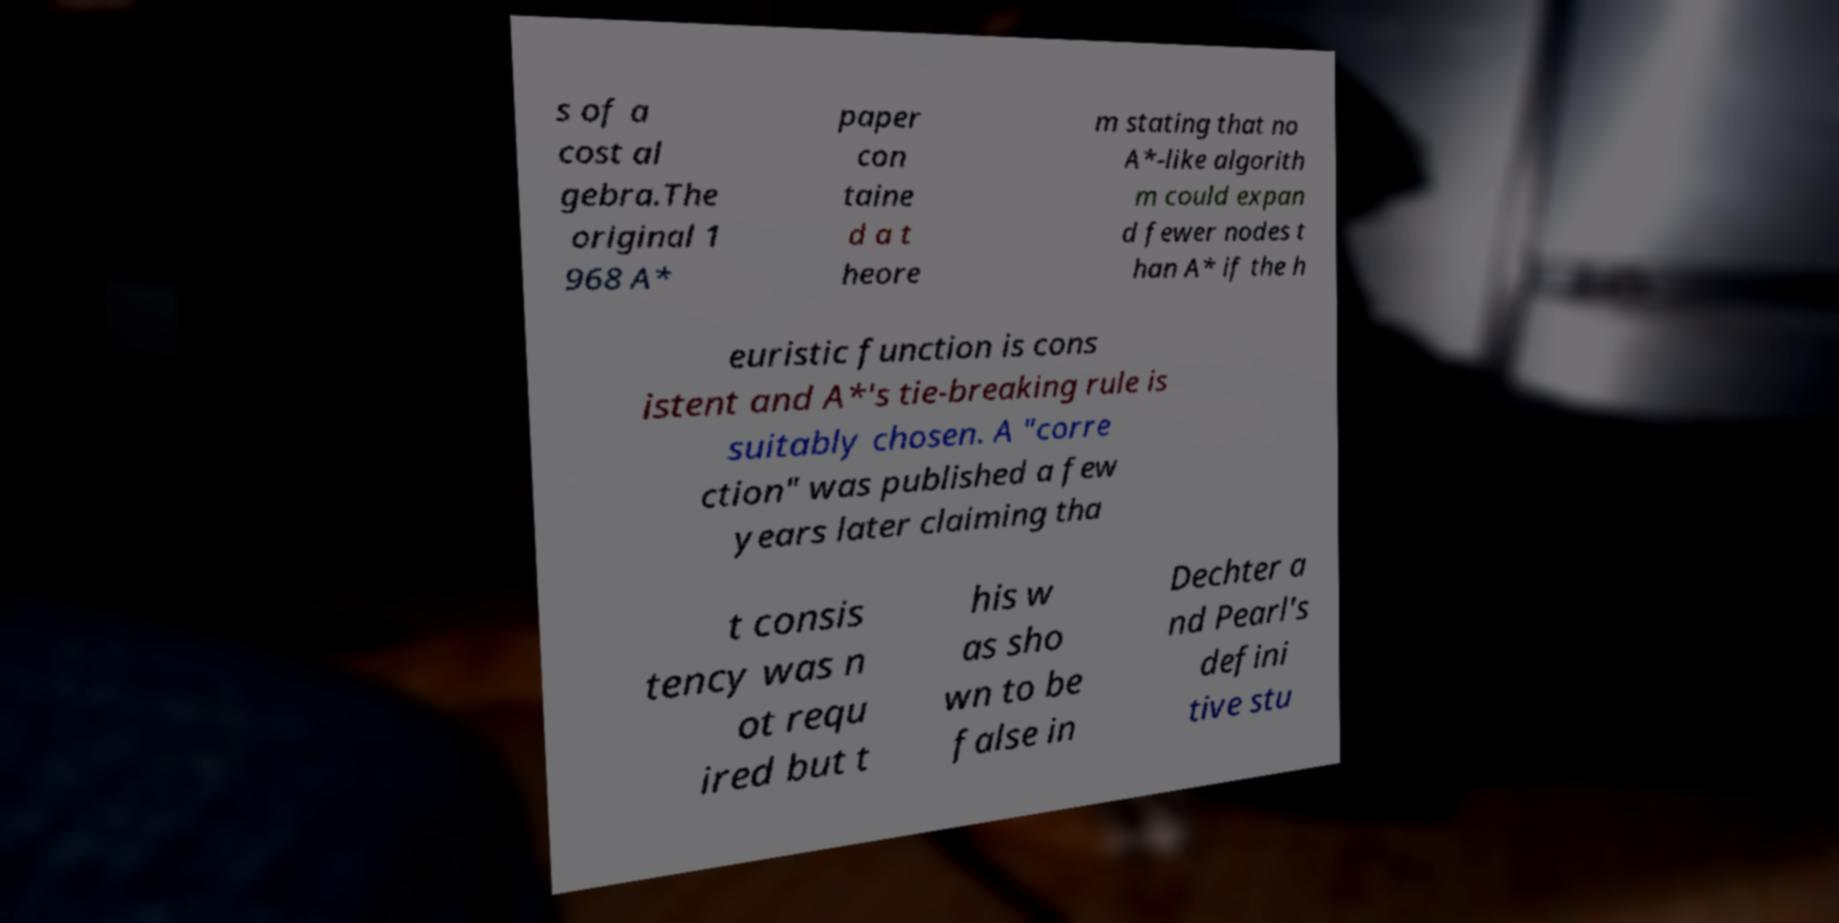I need the written content from this picture converted into text. Can you do that? s of a cost al gebra.The original 1 968 A* paper con taine d a t heore m stating that no A*-like algorith m could expan d fewer nodes t han A* if the h euristic function is cons istent and A*'s tie-breaking rule is suitably chosen. A ″corre ction″ was published a few years later claiming tha t consis tency was n ot requ ired but t his w as sho wn to be false in Dechter a nd Pearl's defini tive stu 